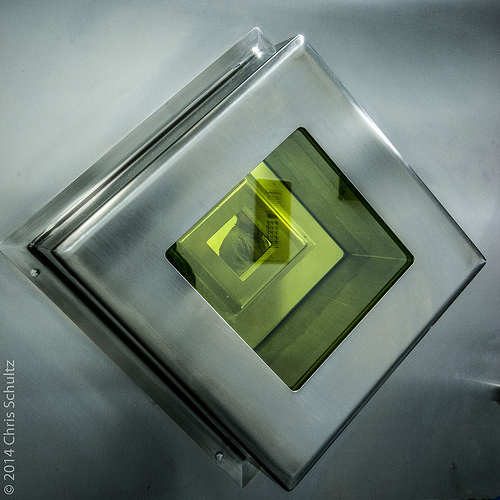<image>
Can you confirm if the person is in front of the door? No. The person is not in front of the door. The spatial positioning shows a different relationship between these objects. 